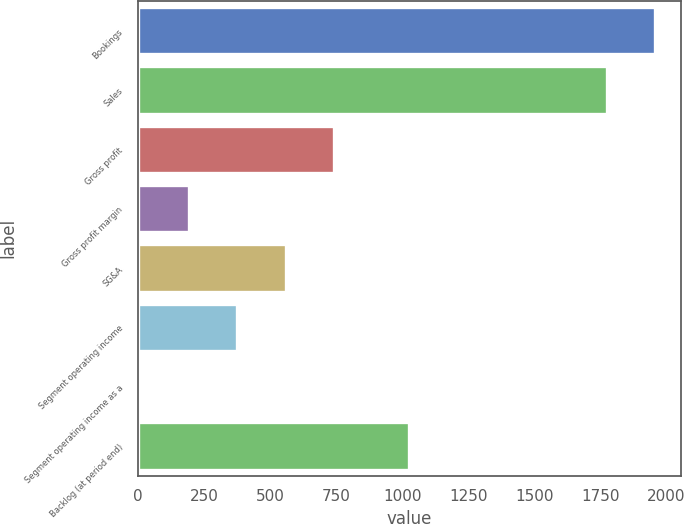Convert chart to OTSL. <chart><loc_0><loc_0><loc_500><loc_500><bar_chart><fcel>Bookings<fcel>Sales<fcel>Gross profit<fcel>Gross profit margin<fcel>SG&A<fcel>Segment operating income<fcel>Segment operating income as a<fcel>Backlog (at period end)<nl><fcel>1958.71<fcel>1775.4<fcel>742.24<fcel>192.31<fcel>558.93<fcel>375.62<fcel>9<fcel>1027.7<nl></chart> 